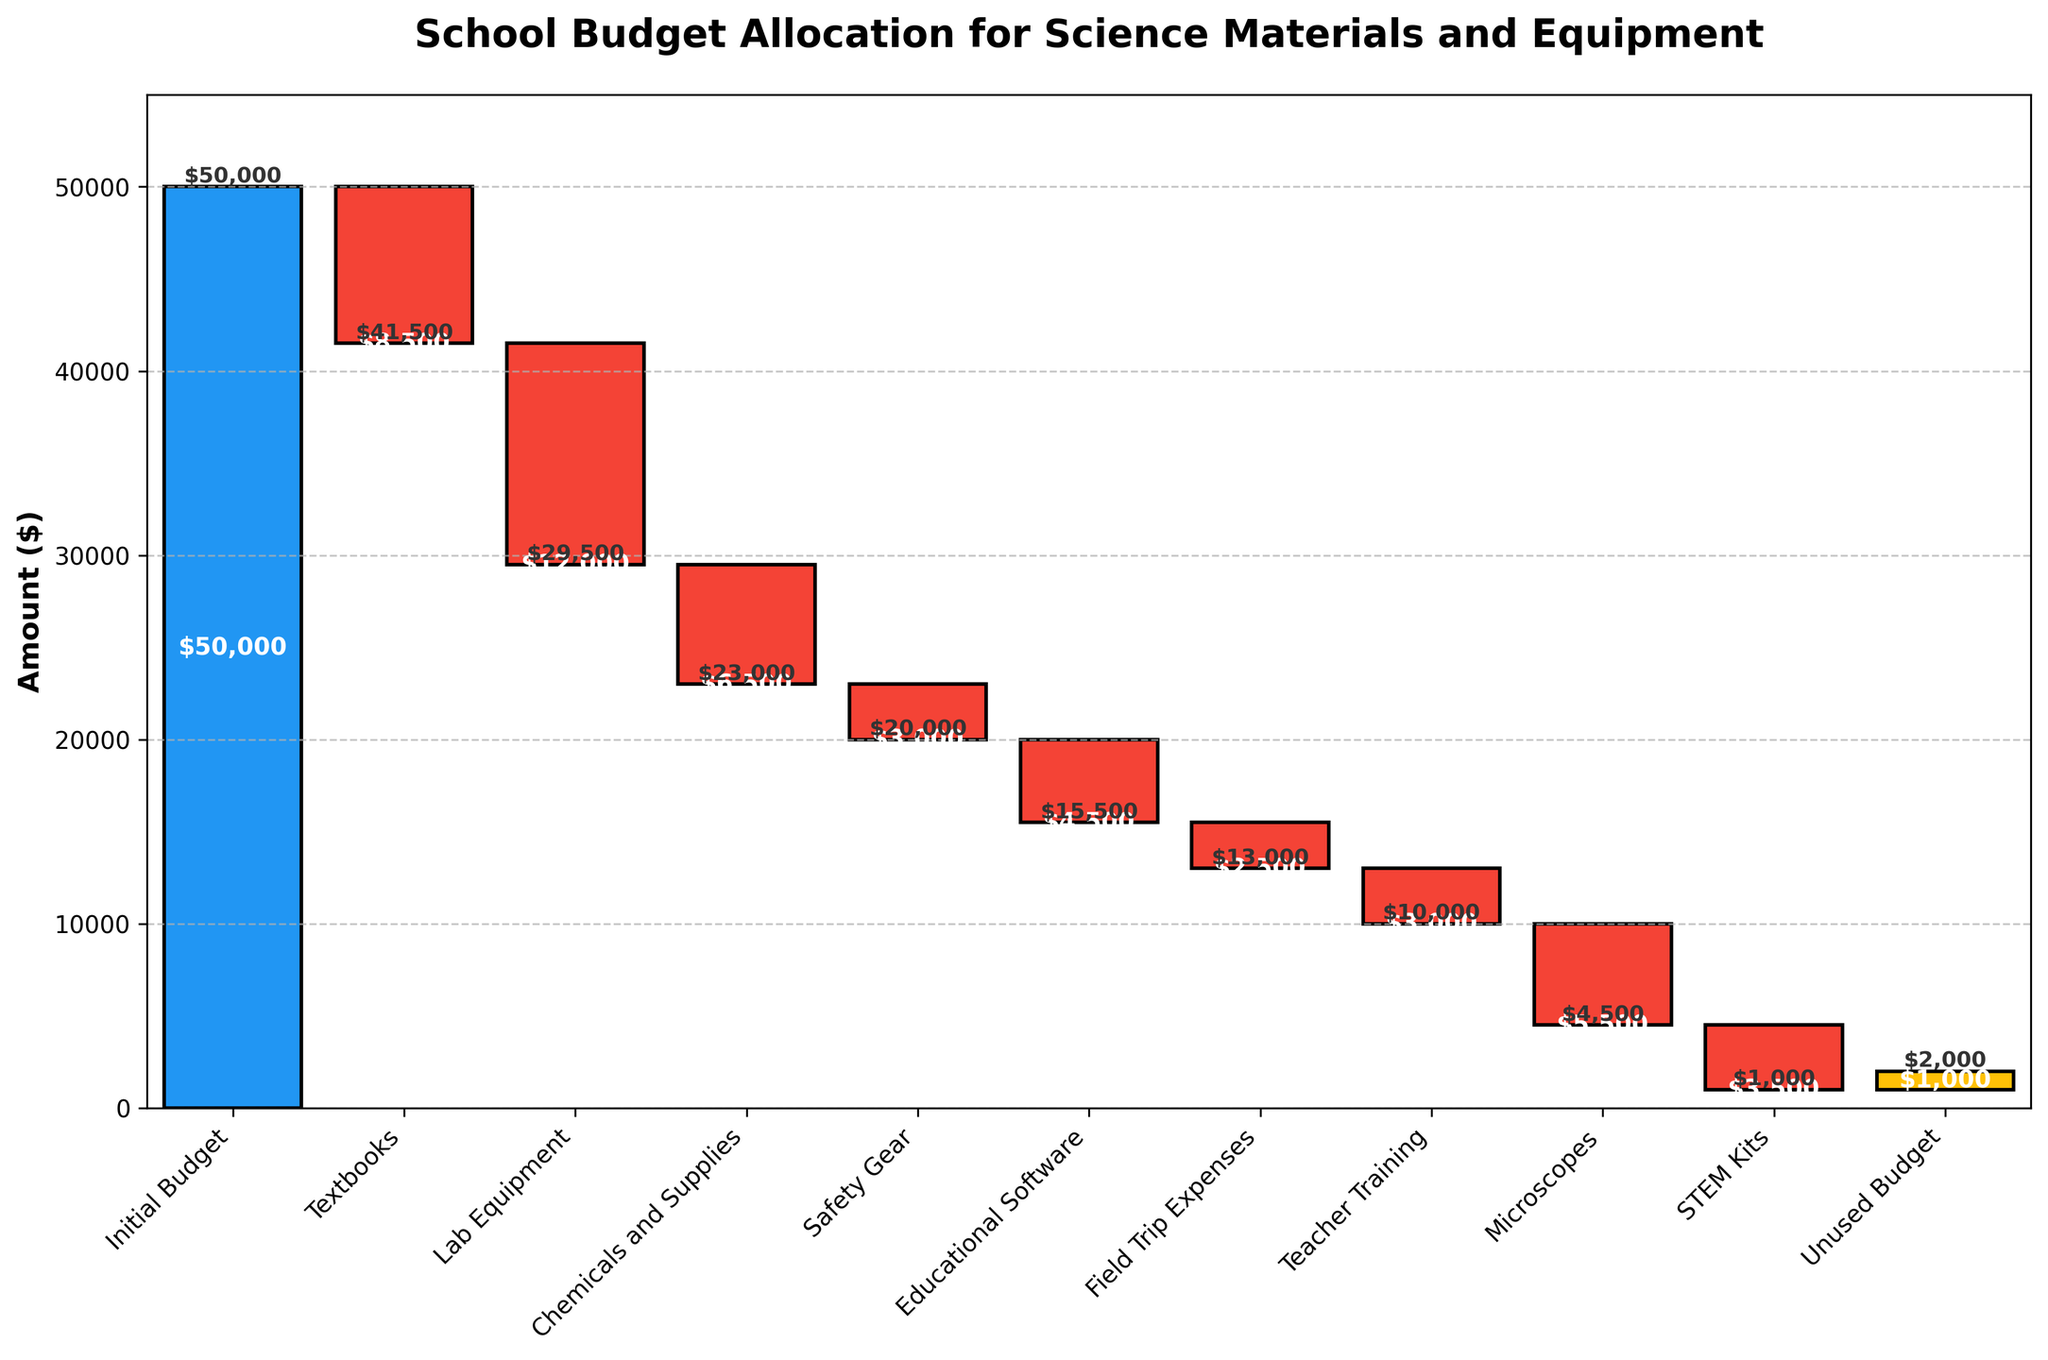What is the total initial budget for science materials and equipment? The initial budget is the first data point in the chart, represented by the blue bar. The title also indicates it's related to school budget allocation for science materials and equipment.
Answer: $50,000 What is the total amount spent on textbooks and lab equipment combined? To find the total amount spent on textbooks and lab equipment, sum the values of these two categories. Textbooks cost $8,500 and lab equipment costs $12,000: $8,500 + $12,000 = $20,500.
Answer: $20,500 Which category has the highest expenditure? Identify the longest red bar, which represents the category with the highest expenditure. Lab equipment has the highest with an expenditure of $12,000.
Answer: Lab equipment How much budget is left unused at the end of the allocation? The unused budget is the last data point in the chart, represented by the yellow bar. The chart indicates that the remaining unused budget is $1,000.
Answer: $1,000 Compare the expenditure on educational software and STEM kits. Which one is higher and by how much? Educational software costs $4,500 and STEM kits cost $3,500. The difference is calculated by subtracting $3,500 from $4,500: $4,500 - $3,500 = $1,000.
Answer: Educational software by $1,000 What is the cumulative budget after spending on chemicals and supplies? The cumulative budget after chemicals and supplies can be found by following the step-by-step cumulative effect in the chart. After chemicals and supplies ($6,500), the remaining budget from $50,000 - $8,500 - $12,000 - $6,500 = $23,000.
Answer: $23,000 Calculate the average spending per category excluding the initial and unused budget. Exclude the initial budget ($50,000) and the unused budget ($1,000). The total expenditure is the sum of all categories: $8,500 + $12,000 + $6,500 + $3,000 + $4,500 + $2,500 + $3,000 + $5,500 + $3,500 = $49,000. There are 9 expenditure categories. So, average spending = $49,000 / 9.
Answer: $5,444.44 What percentage of the initial budget was spent on safety gear? Safety gear expenditure is $3,000. Percentage of the initial budget spent on safety gear is calculated as (3,000 / 50,000) * 100%.
Answer: 6% What is the difference in cumulative budget before and after the purchase of microscopes? Before microscopes, follow the cumulative effect in the chart: from initial budget 50,000 down expenditures to remaining budget ($1,000) - include upto STEM kits. Microscopes is $5,500: before microscopes (after teacher training) is $16,000; after microscopes is $16,000 - $5,500 = $10,500. Difference before and after is $16,000 - $10,500.
Answer: $5,500 